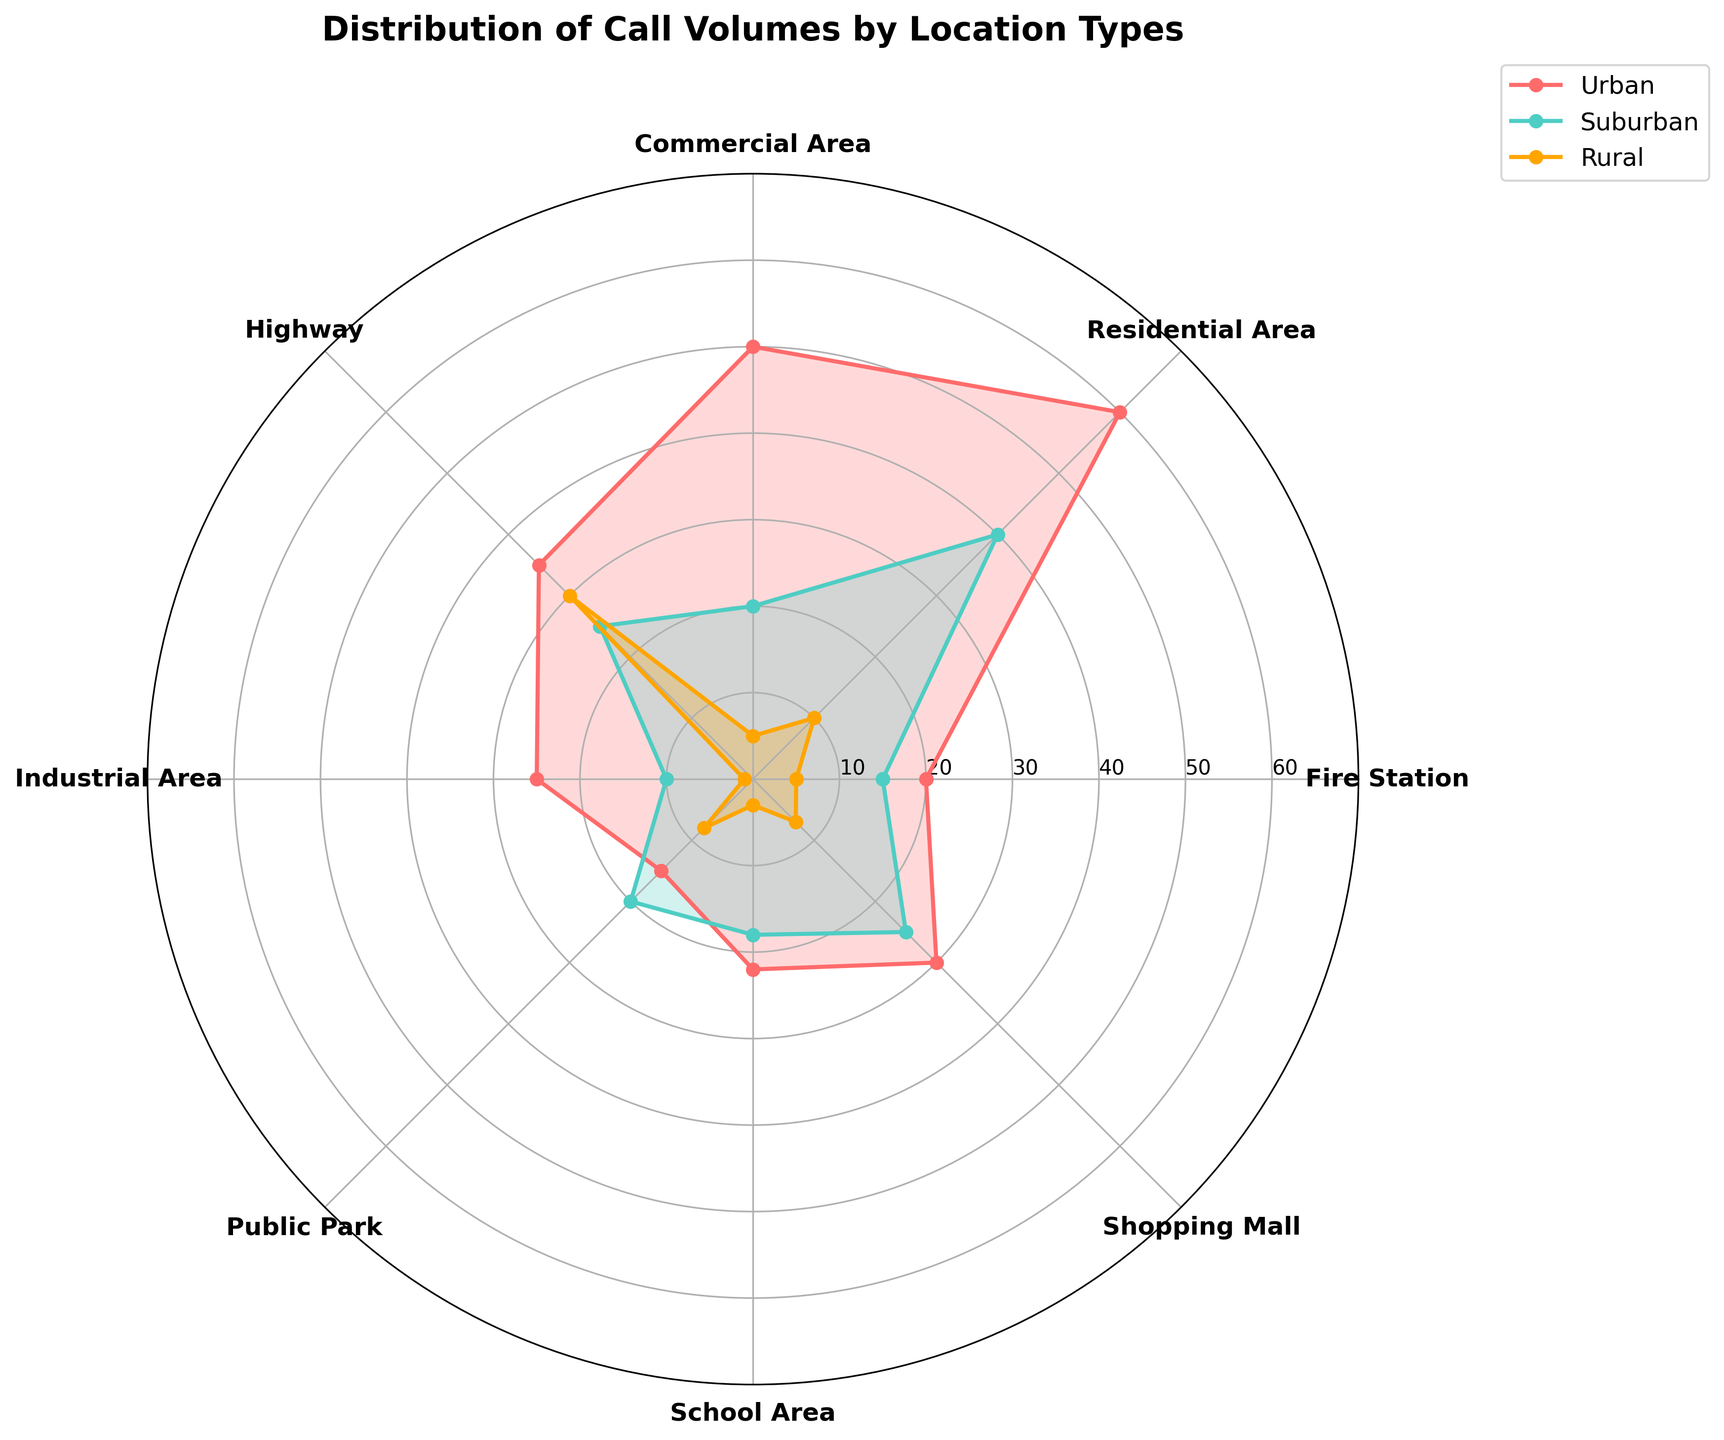what's the title of the figure? The title of the figure is the text displayed prominently at the top. From the code, it specifies that the title is "Distribution of Call Volumes by Location Types".
Answer: Distribution of Call Volumes by Location Types What are the colors used for Urban, Suburban, and Rural locations? The colors are visually distinct and each category uses a specific color. From the code, Urban is displayed in red, Suburban in teal, and Rural in orange.
Answer: Urban: Red, Suburban: Teal, Rural: Orange Which location type has the highest call volume in Urban areas? By looking at the data and the plotted polar chart, check the highest call volume value among the urban areas. Residential Area in the Urban category has the highest call volume of 60.
Answer: Residential Area How many location types have a call volume of 25 in Urban areas? Count the location types where the call volume is exactly 25 in Urban areas by looking at the plot. Industrial Area has 25.
Answer: 1 Comparing Suburban and Rural areas, which location experienced higher call volumes in Public Parks? Compare the height of the data points for Suburban and Rural areas specific to Public Parks. The value for Public Parks is higher in Suburban (20) than in Rural (8).
Answer: Suburban What's the average call volume in Rural areas considering all location types? Add all the call volumes in the Rural category then divide by the number of locations. (5+10+5+30+1+8+3+7) / 8 = 69 / 8 ≈ 8.625
Answer: 8.625 Which location type had the least call volume in both Urban and Rural areas? Find the minimum value in both Urban and Rural categories and identify the location types. Industrial Area in Rural (1) and Fire Station in Urban (20). The general minimum call volume is in Industrial Area, Rural.
Answer: Industrial Area (Rural) What's the difference in call volumes between Residential Areas in Urban and Suburban locations? Subtract the call volume of Residential Areas in Suburban from Urban. 60 (Urban) - 40 (Suburban) = 20.
Answer: 20 Do any location types show equal call volumes for all three (Urban, Suburban, Rural) areas? Check visually if any points are aligned equally across all three areas in the plot or add and compare the values from each area. No location types have equal call volumes across Urban, Suburban, and Rural categories.
Answer: No Which area has a call volume exceeding 50 only in Urban locations? Review the chart and find values greater than 50 in Urban locations, ensuring those volumes are not replicated in Suburban or Rural areas. Commercial Area (50) and Residential Area (60) qualify but only Residential exceeds 50.
Answer: Residential Area 